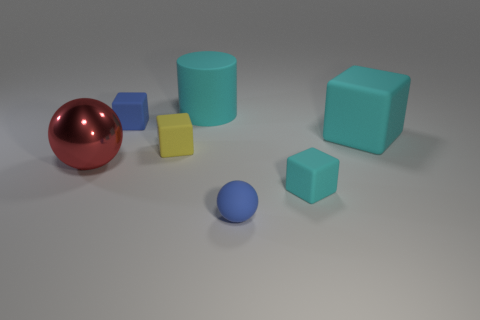Subtract 1 blocks. How many blocks are left? 3 Add 2 gray matte spheres. How many objects exist? 9 Subtract all cubes. How many objects are left? 3 Add 1 tiny yellow matte things. How many tiny yellow matte things are left? 2 Add 7 red things. How many red things exist? 8 Subtract 1 cyan cylinders. How many objects are left? 6 Subtract all blue objects. Subtract all metal things. How many objects are left? 4 